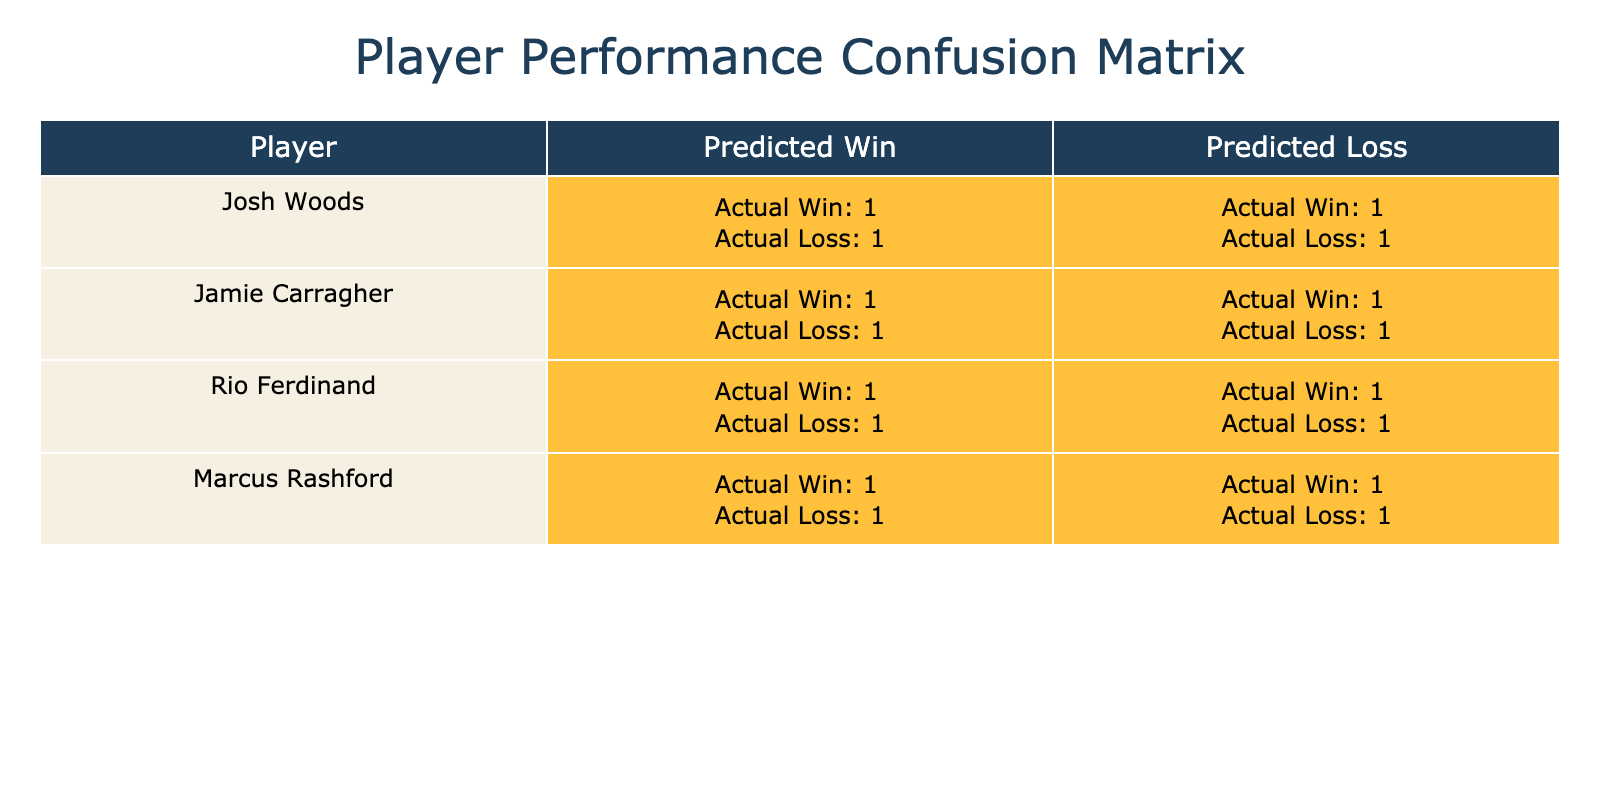What is the total number of wins predicted for Josh Woods? The table shows that the predicted wins for Josh Woods are 2. We find this by looking at the predicted outcome for the result that aligns with the actual outcome of a win, which gives us 'Win,Win' entries. Counting these entries results in 2 wins.
Answer: 2 What is the total number of losses predicted for Jamie Carragher? For Jamie Carragher, the predicted losses are found under the predicted outcome where the actual outcome is 'Loss'. The entries 'Win,Loss' and 'Loss,Loss' contribute to a total of 2.
Answer: 2 Did Marcus Rashford get more predicted wins or predicted losses? In the case of Marcus Rashford, he has a total of 2 predicted wins (entries that match 'Win,Win') and 2 predicted losses (with 'Win,Loss' and 'Loss,Loss'). Since the counts are equal, we can conclude that he did not get more of either.
Answer: No What is the difference between the predicted wins and losses for Rio Ferdinand? Observing Rio Ferdinand’s data, he has a total of 2 predicted wins and 2 predicted losses. The difference is found by subtracting the number of predicted losses from the number of predicted wins, resulting in a difference of 0.
Answer: 0 How many players have an equal number of predicted wins and losses? By analyzing the data, both Marcus Rashford and Rio Ferdinand have equal counts of predicted wins (2) and losses (2). This means they are among the players who showcase this characteristic in the table.
Answer: 2 Did Josh Woods predict more wins compared to Jamie Carragher? Josh Woods predicted 2 wins while Jamie Carragher predicted 1 win ('Win,Win’ case). Since 2 is greater than 1, we conclude that Josh Woods indeed predicted more wins than Jamie Carragher.
Answer: Yes Which player has the highest number of predicted losses? Upon reviewing the data, we see that all players have an equal number of predicted losses, which amounts to 2 each for the losses. The table does not display any player with more than 2 predicted losses.
Answer: None What are the actual outcomes when the predicted outcome is "Win" for Marcus Rashford? The entries for Marcus Rashford's predicted outcome "Win" reference 2 actual outcomes: 2 wins and 1 loss. This can be depicted by counting the entries under his name that denote a predicted 'Win'.
Answer: 2 Wins, 1 Loss 